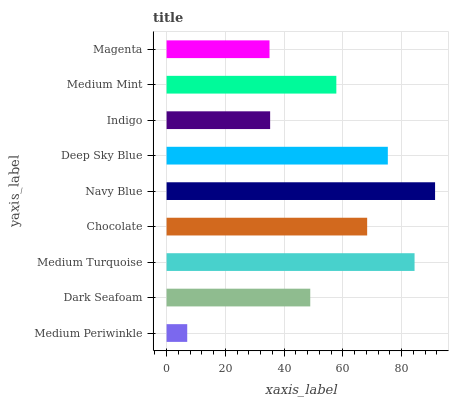Is Medium Periwinkle the minimum?
Answer yes or no. Yes. Is Navy Blue the maximum?
Answer yes or no. Yes. Is Dark Seafoam the minimum?
Answer yes or no. No. Is Dark Seafoam the maximum?
Answer yes or no. No. Is Dark Seafoam greater than Medium Periwinkle?
Answer yes or no. Yes. Is Medium Periwinkle less than Dark Seafoam?
Answer yes or no. Yes. Is Medium Periwinkle greater than Dark Seafoam?
Answer yes or no. No. Is Dark Seafoam less than Medium Periwinkle?
Answer yes or no. No. Is Medium Mint the high median?
Answer yes or no. Yes. Is Medium Mint the low median?
Answer yes or no. Yes. Is Medium Turquoise the high median?
Answer yes or no. No. Is Deep Sky Blue the low median?
Answer yes or no. No. 